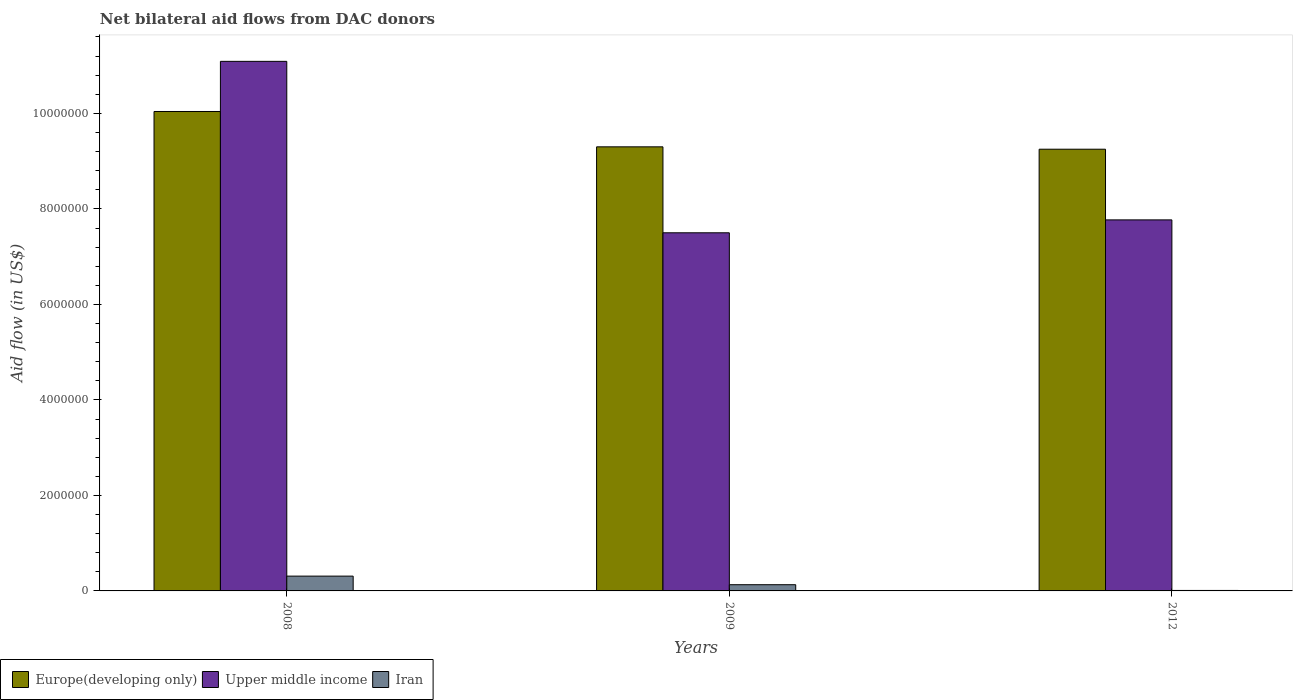How many different coloured bars are there?
Offer a terse response. 3. How many groups of bars are there?
Offer a terse response. 3. Are the number of bars per tick equal to the number of legend labels?
Give a very brief answer. Yes. Are the number of bars on each tick of the X-axis equal?
Offer a very short reply. Yes. What is the net bilateral aid flow in Europe(developing only) in 2009?
Give a very brief answer. 9.30e+06. Across all years, what is the maximum net bilateral aid flow in Iran?
Your answer should be very brief. 3.10e+05. Across all years, what is the minimum net bilateral aid flow in Europe(developing only)?
Your answer should be compact. 9.25e+06. In which year was the net bilateral aid flow in Europe(developing only) minimum?
Give a very brief answer. 2012. What is the total net bilateral aid flow in Europe(developing only) in the graph?
Give a very brief answer. 2.86e+07. What is the difference between the net bilateral aid flow in Upper middle income in 2008 and that in 2009?
Your answer should be compact. 3.59e+06. What is the difference between the net bilateral aid flow in Europe(developing only) in 2009 and the net bilateral aid flow in Iran in 2012?
Provide a succinct answer. 9.29e+06. What is the average net bilateral aid flow in Europe(developing only) per year?
Ensure brevity in your answer.  9.53e+06. In the year 2008, what is the difference between the net bilateral aid flow in Upper middle income and net bilateral aid flow in Iran?
Make the answer very short. 1.08e+07. What is the ratio of the net bilateral aid flow in Upper middle income in 2008 to that in 2009?
Keep it short and to the point. 1.48. What is the difference between the highest and the second highest net bilateral aid flow in Europe(developing only)?
Ensure brevity in your answer.  7.40e+05. What is the difference between the highest and the lowest net bilateral aid flow in Europe(developing only)?
Your response must be concise. 7.90e+05. What does the 3rd bar from the left in 2009 represents?
Keep it short and to the point. Iran. What does the 1st bar from the right in 2008 represents?
Keep it short and to the point. Iran. How many bars are there?
Your answer should be very brief. 9. Are the values on the major ticks of Y-axis written in scientific E-notation?
Provide a short and direct response. No. Does the graph contain any zero values?
Make the answer very short. No. Does the graph contain grids?
Your answer should be very brief. No. Where does the legend appear in the graph?
Offer a terse response. Bottom left. How are the legend labels stacked?
Offer a terse response. Horizontal. What is the title of the graph?
Provide a succinct answer. Net bilateral aid flows from DAC donors. Does "Euro area" appear as one of the legend labels in the graph?
Offer a terse response. No. What is the label or title of the X-axis?
Your response must be concise. Years. What is the label or title of the Y-axis?
Offer a terse response. Aid flow (in US$). What is the Aid flow (in US$) in Europe(developing only) in 2008?
Your answer should be very brief. 1.00e+07. What is the Aid flow (in US$) of Upper middle income in 2008?
Offer a very short reply. 1.11e+07. What is the Aid flow (in US$) of Europe(developing only) in 2009?
Provide a short and direct response. 9.30e+06. What is the Aid flow (in US$) in Upper middle income in 2009?
Offer a terse response. 7.50e+06. What is the Aid flow (in US$) of Europe(developing only) in 2012?
Offer a very short reply. 9.25e+06. What is the Aid flow (in US$) of Upper middle income in 2012?
Make the answer very short. 7.77e+06. What is the Aid flow (in US$) in Iran in 2012?
Offer a terse response. 10000. Across all years, what is the maximum Aid flow (in US$) of Europe(developing only)?
Your answer should be compact. 1.00e+07. Across all years, what is the maximum Aid flow (in US$) of Upper middle income?
Your answer should be compact. 1.11e+07. Across all years, what is the maximum Aid flow (in US$) of Iran?
Your answer should be compact. 3.10e+05. Across all years, what is the minimum Aid flow (in US$) in Europe(developing only)?
Provide a short and direct response. 9.25e+06. Across all years, what is the minimum Aid flow (in US$) in Upper middle income?
Offer a very short reply. 7.50e+06. What is the total Aid flow (in US$) of Europe(developing only) in the graph?
Your answer should be compact. 2.86e+07. What is the total Aid flow (in US$) of Upper middle income in the graph?
Your answer should be very brief. 2.64e+07. What is the difference between the Aid flow (in US$) of Europe(developing only) in 2008 and that in 2009?
Ensure brevity in your answer.  7.40e+05. What is the difference between the Aid flow (in US$) in Upper middle income in 2008 and that in 2009?
Offer a terse response. 3.59e+06. What is the difference between the Aid flow (in US$) of Europe(developing only) in 2008 and that in 2012?
Offer a very short reply. 7.90e+05. What is the difference between the Aid flow (in US$) in Upper middle income in 2008 and that in 2012?
Ensure brevity in your answer.  3.32e+06. What is the difference between the Aid flow (in US$) in Iran in 2008 and that in 2012?
Make the answer very short. 3.00e+05. What is the difference between the Aid flow (in US$) in Europe(developing only) in 2008 and the Aid flow (in US$) in Upper middle income in 2009?
Keep it short and to the point. 2.54e+06. What is the difference between the Aid flow (in US$) in Europe(developing only) in 2008 and the Aid flow (in US$) in Iran in 2009?
Offer a terse response. 9.91e+06. What is the difference between the Aid flow (in US$) in Upper middle income in 2008 and the Aid flow (in US$) in Iran in 2009?
Your answer should be very brief. 1.10e+07. What is the difference between the Aid flow (in US$) of Europe(developing only) in 2008 and the Aid flow (in US$) of Upper middle income in 2012?
Give a very brief answer. 2.27e+06. What is the difference between the Aid flow (in US$) of Europe(developing only) in 2008 and the Aid flow (in US$) of Iran in 2012?
Provide a succinct answer. 1.00e+07. What is the difference between the Aid flow (in US$) in Upper middle income in 2008 and the Aid flow (in US$) in Iran in 2012?
Provide a succinct answer. 1.11e+07. What is the difference between the Aid flow (in US$) of Europe(developing only) in 2009 and the Aid flow (in US$) of Upper middle income in 2012?
Your response must be concise. 1.53e+06. What is the difference between the Aid flow (in US$) in Europe(developing only) in 2009 and the Aid flow (in US$) in Iran in 2012?
Offer a terse response. 9.29e+06. What is the difference between the Aid flow (in US$) in Upper middle income in 2009 and the Aid flow (in US$) in Iran in 2012?
Keep it short and to the point. 7.49e+06. What is the average Aid flow (in US$) of Europe(developing only) per year?
Give a very brief answer. 9.53e+06. What is the average Aid flow (in US$) of Upper middle income per year?
Provide a succinct answer. 8.79e+06. What is the average Aid flow (in US$) in Iran per year?
Your answer should be compact. 1.50e+05. In the year 2008, what is the difference between the Aid flow (in US$) of Europe(developing only) and Aid flow (in US$) of Upper middle income?
Give a very brief answer. -1.05e+06. In the year 2008, what is the difference between the Aid flow (in US$) in Europe(developing only) and Aid flow (in US$) in Iran?
Ensure brevity in your answer.  9.73e+06. In the year 2008, what is the difference between the Aid flow (in US$) in Upper middle income and Aid flow (in US$) in Iran?
Offer a terse response. 1.08e+07. In the year 2009, what is the difference between the Aid flow (in US$) in Europe(developing only) and Aid flow (in US$) in Upper middle income?
Offer a terse response. 1.80e+06. In the year 2009, what is the difference between the Aid flow (in US$) of Europe(developing only) and Aid flow (in US$) of Iran?
Offer a very short reply. 9.17e+06. In the year 2009, what is the difference between the Aid flow (in US$) of Upper middle income and Aid flow (in US$) of Iran?
Provide a succinct answer. 7.37e+06. In the year 2012, what is the difference between the Aid flow (in US$) in Europe(developing only) and Aid flow (in US$) in Upper middle income?
Provide a succinct answer. 1.48e+06. In the year 2012, what is the difference between the Aid flow (in US$) of Europe(developing only) and Aid flow (in US$) of Iran?
Your answer should be very brief. 9.24e+06. In the year 2012, what is the difference between the Aid flow (in US$) in Upper middle income and Aid flow (in US$) in Iran?
Ensure brevity in your answer.  7.76e+06. What is the ratio of the Aid flow (in US$) in Europe(developing only) in 2008 to that in 2009?
Provide a short and direct response. 1.08. What is the ratio of the Aid flow (in US$) in Upper middle income in 2008 to that in 2009?
Your response must be concise. 1.48. What is the ratio of the Aid flow (in US$) in Iran in 2008 to that in 2009?
Provide a succinct answer. 2.38. What is the ratio of the Aid flow (in US$) in Europe(developing only) in 2008 to that in 2012?
Make the answer very short. 1.09. What is the ratio of the Aid flow (in US$) of Upper middle income in 2008 to that in 2012?
Make the answer very short. 1.43. What is the ratio of the Aid flow (in US$) of Europe(developing only) in 2009 to that in 2012?
Your answer should be very brief. 1.01. What is the ratio of the Aid flow (in US$) of Upper middle income in 2009 to that in 2012?
Your response must be concise. 0.97. What is the difference between the highest and the second highest Aid flow (in US$) in Europe(developing only)?
Make the answer very short. 7.40e+05. What is the difference between the highest and the second highest Aid flow (in US$) of Upper middle income?
Offer a very short reply. 3.32e+06. What is the difference between the highest and the lowest Aid flow (in US$) of Europe(developing only)?
Keep it short and to the point. 7.90e+05. What is the difference between the highest and the lowest Aid flow (in US$) in Upper middle income?
Your response must be concise. 3.59e+06. What is the difference between the highest and the lowest Aid flow (in US$) in Iran?
Keep it short and to the point. 3.00e+05. 